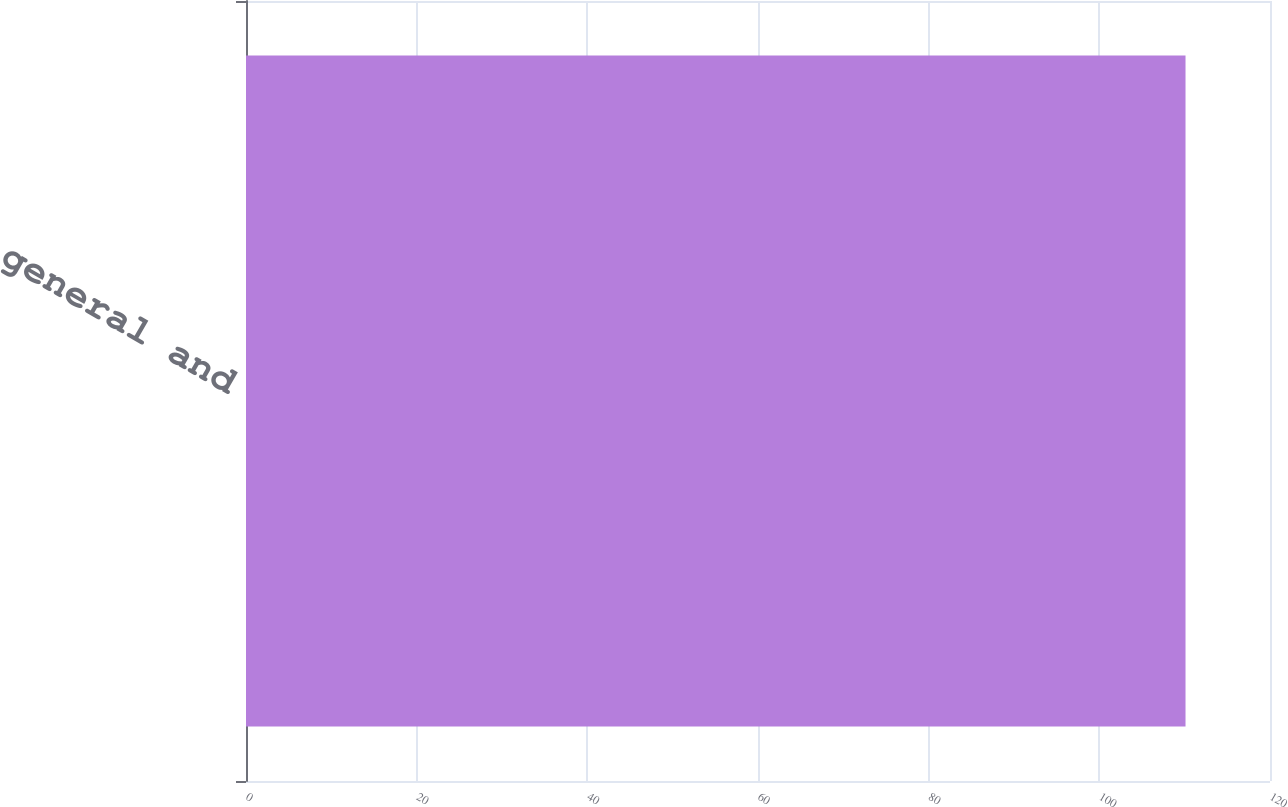<chart> <loc_0><loc_0><loc_500><loc_500><bar_chart><fcel>Selling general and<nl><fcel>110.1<nl></chart> 